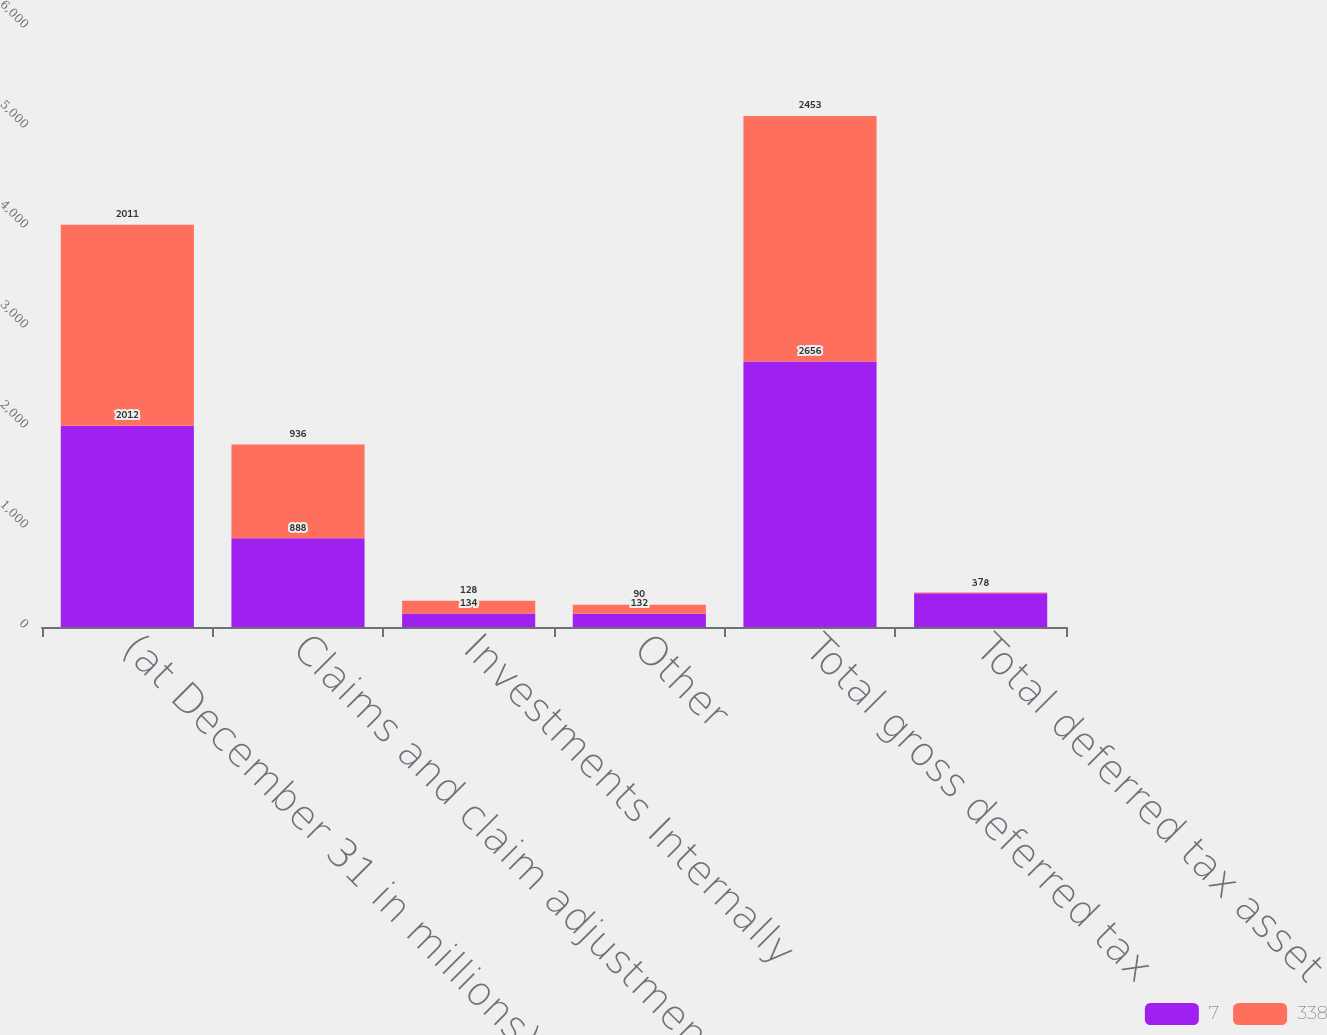Convert chart. <chart><loc_0><loc_0><loc_500><loc_500><stacked_bar_chart><ecel><fcel>(at December 31 in millions)<fcel>Claims and claim adjustment<fcel>Investments Internally<fcel>Other<fcel>Total gross deferred tax<fcel>Total deferred tax asset<nl><fcel>7<fcel>2012<fcel>888<fcel>134<fcel>132<fcel>2656<fcel>338<nl><fcel>338<fcel>2011<fcel>936<fcel>128<fcel>90<fcel>2453<fcel>7<nl></chart> 